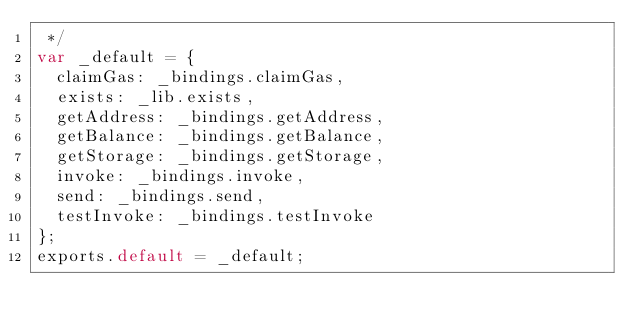<code> <loc_0><loc_0><loc_500><loc_500><_JavaScript_> */
var _default = {
  claimGas: _bindings.claimGas,
  exists: _lib.exists,
  getAddress: _bindings.getAddress,
  getBalance: _bindings.getBalance,
  getStorage: _bindings.getStorage,
  invoke: _bindings.invoke,
  send: _bindings.send,
  testInvoke: _bindings.testInvoke
};
exports.default = _default;</code> 